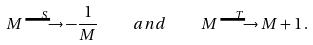<formula> <loc_0><loc_0><loc_500><loc_500>M \stackrel { S } { \longrightarrow } - \frac { 1 } { M } \quad a n d \quad M \stackrel { T } { \longrightarrow } M + 1 \, .</formula> 